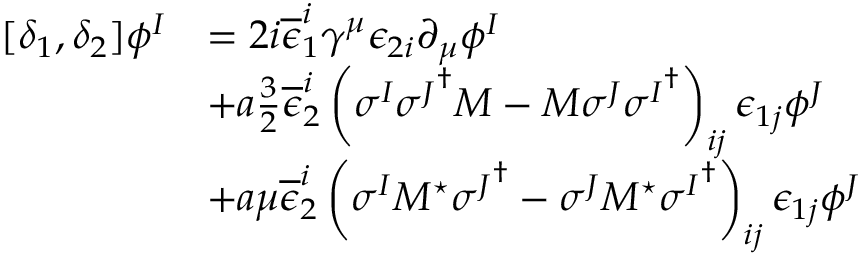<formula> <loc_0><loc_0><loc_500><loc_500>\begin{array} { l l } { { [ \delta _ { 1 } , \delta _ { 2 } ] \phi ^ { I } } } & { { = 2 i \overline { \epsilon } _ { 1 } ^ { i } \gamma ^ { \mu } \epsilon _ { 2 i } \partial _ { \mu } \phi ^ { I } } } & { { + a \frac { 3 } { 2 } \overline { \epsilon } _ { 2 } ^ { i } \left ( \sigma ^ { I } { \sigma ^ { J } } ^ { \dagger } M - M \sigma ^ { J } { \sigma ^ { I } } ^ { \dagger } \right ) _ { i j } \epsilon _ { 1 j } \phi ^ { J } } } & { { + a \mu \overline { \epsilon } _ { 2 } ^ { i } \left ( \sigma ^ { I } M ^ { ^ { * } } { \sigma ^ { J } } ^ { \dagger } - \sigma ^ { J } M ^ { ^ { * } } { \sigma ^ { I } } ^ { \dagger } \right ) _ { i j } \epsilon _ { 1 j } \phi ^ { J } } } \end{array}</formula> 